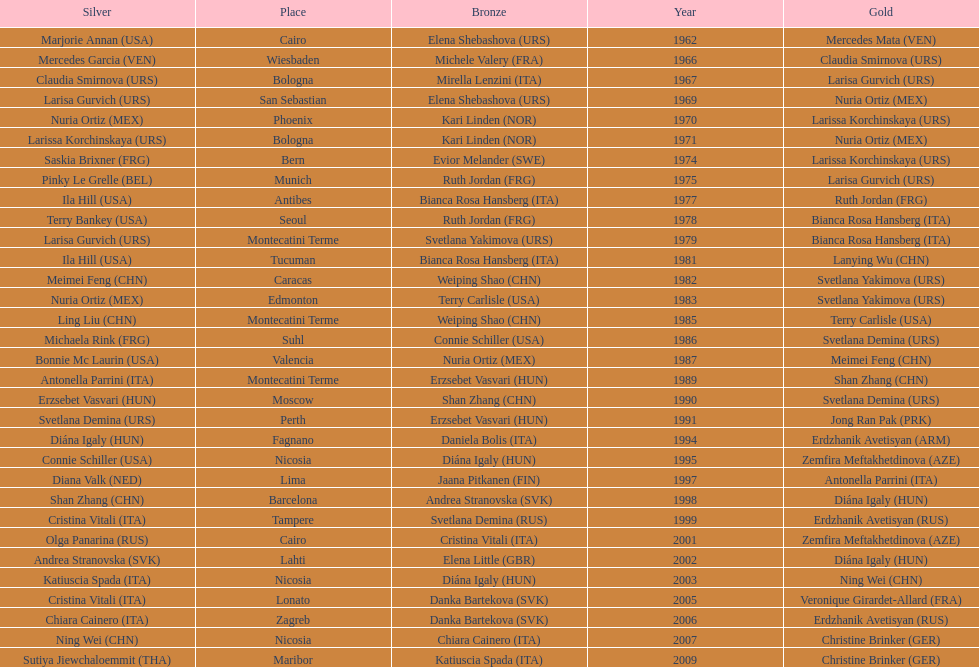What is the total of silver for cairo 0. 